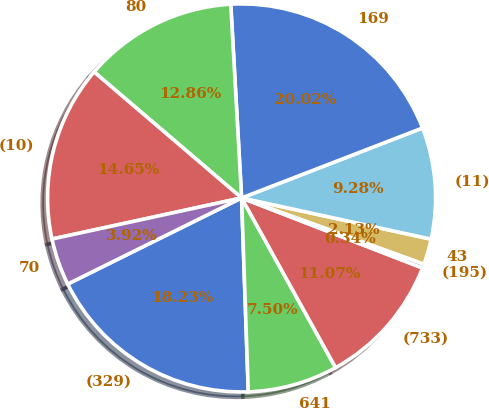Convert chart. <chart><loc_0><loc_0><loc_500><loc_500><pie_chart><fcel>(329)<fcel>641<fcel>(733)<fcel>(195)<fcel>43<fcel>(11)<fcel>169<fcel>80<fcel>(10)<fcel>70<nl><fcel>18.23%<fcel>7.5%<fcel>11.07%<fcel>0.34%<fcel>2.13%<fcel>9.28%<fcel>20.02%<fcel>12.86%<fcel>14.65%<fcel>3.92%<nl></chart> 